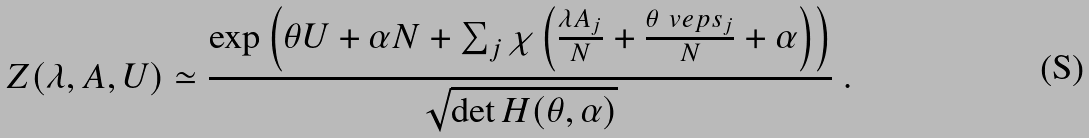<formula> <loc_0><loc_0><loc_500><loc_500>Z ( \lambda , A , U ) \simeq \frac { \exp \left ( \theta U + \alpha N + \sum _ { j } \chi \left ( \frac { \lambda A _ { j } } { N } + \frac { \theta \ v e p s _ { j } } { N } + \alpha \right ) \right ) } { \sqrt { \det H ( \theta , \alpha ) } } \ .</formula> 